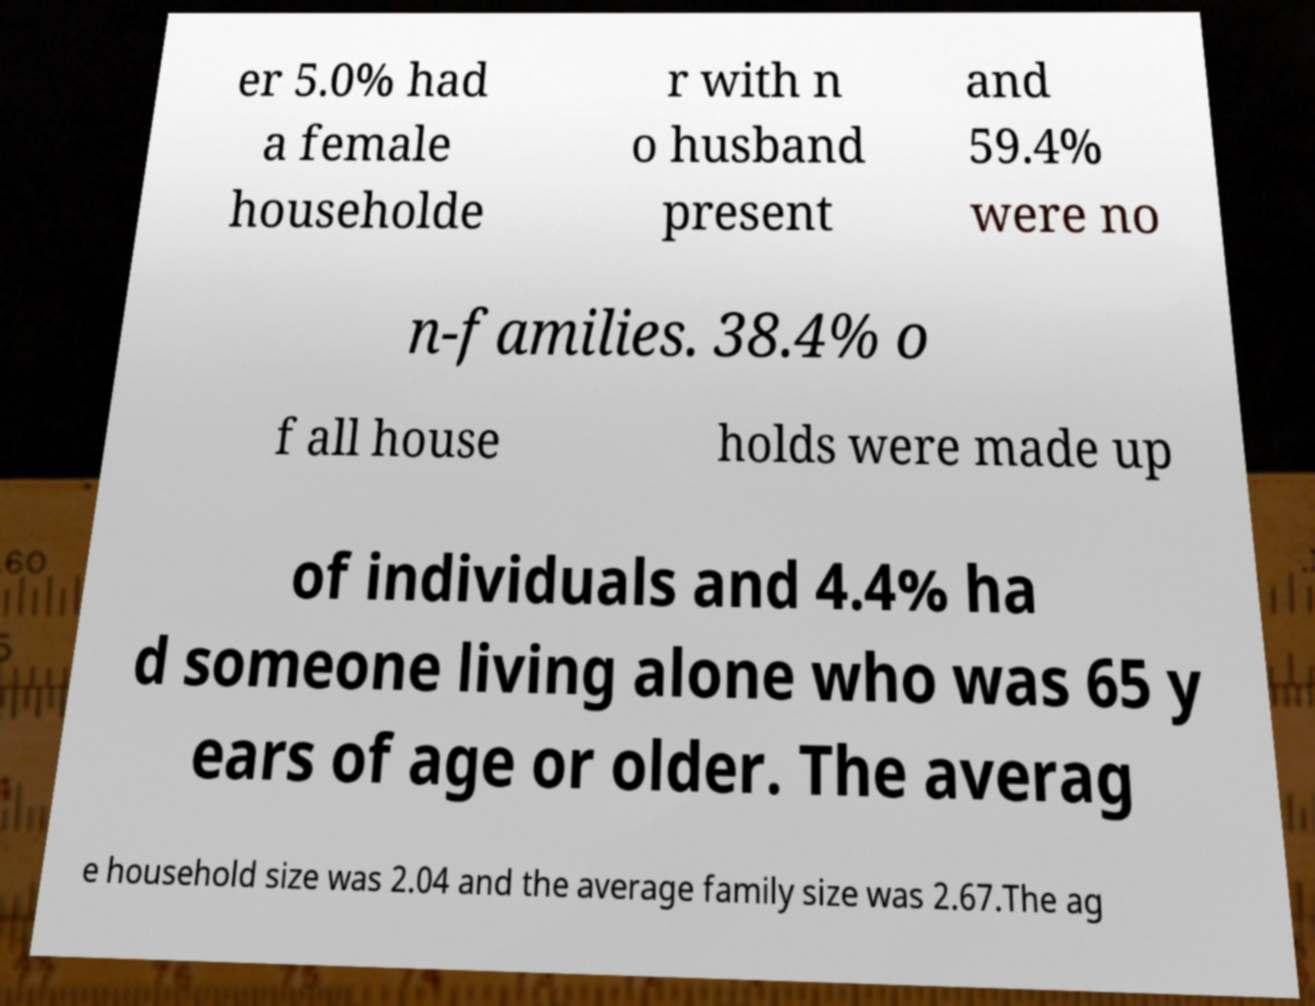Can you read and provide the text displayed in the image?This photo seems to have some interesting text. Can you extract and type it out for me? er 5.0% had a female householde r with n o husband present and 59.4% were no n-families. 38.4% o f all house holds were made up of individuals and 4.4% ha d someone living alone who was 65 y ears of age or older. The averag e household size was 2.04 and the average family size was 2.67.The ag 